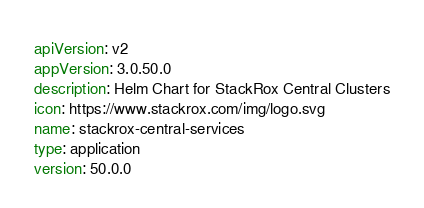<code> <loc_0><loc_0><loc_500><loc_500><_YAML_>apiVersion: v2
appVersion: 3.0.50.0
description: Helm Chart for StackRox Central Clusters
icon: https://www.stackrox.com/img/logo.svg
name: stackrox-central-services
type: application
version: 50.0.0
</code> 